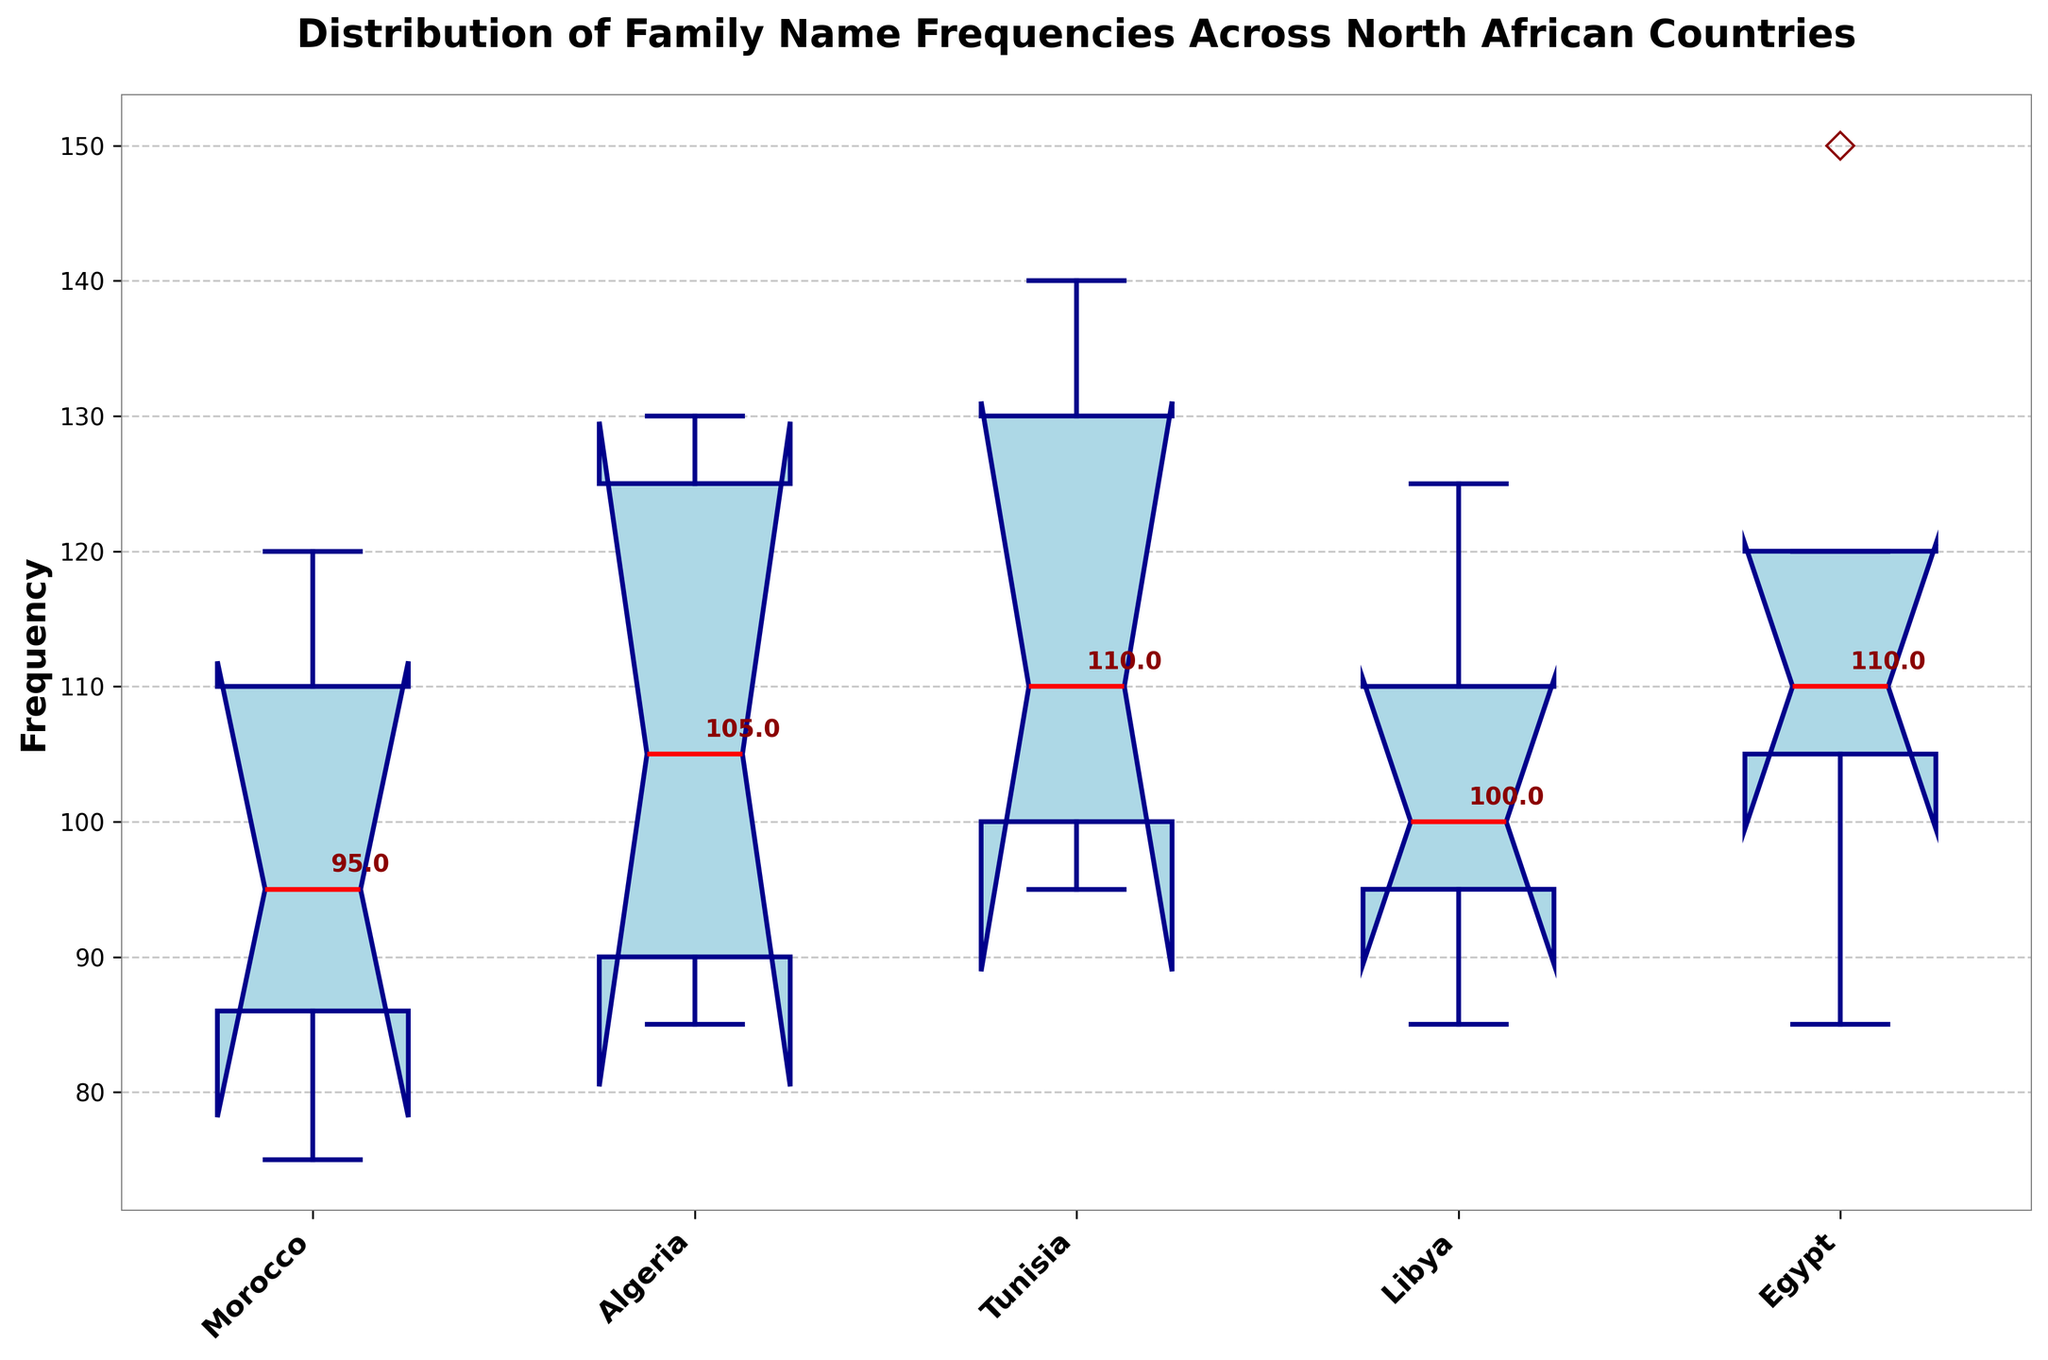What's the title of the figure? The title is usually located at the top of the plot. In this case, it reads "Distribution of Family Name Frequencies Across North African Countries".
Answer: Distribution of Family Name Frequencies Across North African Countries What information is displayed on the y-axis? The y-axis in this figure shows the frequency of family names. This can be identified by the label "Frequency" on the y-axis.
Answer: Frequency Which country has the highest median family name frequency? The median values are identified by the red lines within the boxes. We can look at each country and see which median line is at the highest y-value. In this case, Tunisia seems to have the highest median.
Answer: Tunisia What is the range of the family name frequencies for Morocco? The range consists of the difference between the maximum and minimum values within the whiskers for Morocco. The box plot for Morocco shows that the maximum is about 120 and the minimum is about 75. Therefore, the range is 120 - 75 = 45.
Answer: 45 Which country has the most outliers? Outliers are represented by points outside the whiskers of the box plot, generally marked with distinct symbols like a diamond. Observing the plot, Tunisia has the highest number of outliers.
Answer: Tunisia What do the notches in the box plots represent? Notches in a box plot represent a confidence interval around the median, usually a 95% confidence interval. This helps indicate if medians are significantly different; if the notches of two boxes do not overlap, it suggests a statistically significant difference in medians.
Answer: Confidence interval around the median Which country has the smallest interquartile range (IQR)? The IQR is the length of the box in each box plot. By visually inspecting the height of the boxes, Algeria appears to have the smallest IQR.
Answer: Algeria Compare the median frequency of family names between Egypt and Libya. Which one is higher? To compare the medians, look at the red lines within the boxes for Egypt and Libya. The median value for Egypt is higher than that for Libya.
Answer: Egypt What can be inferred if the notches of two box plots do not overlap? When the notches of two box plots do not overlap, it suggests there is a statistically significant difference between the medians of the two groups. This can be inferred based on the construction of notches representing confidence intervals.
Answer: Statistically significant difference between medians How can the presence of outliers affect the interpretation of the data for a specific country? The presence of outliers indicates that there are family names with frequencies significantly different from the rest of the data set. This can impact the analysis by indicating higher variability or suggesting the need to investigate those specific family names further.
Answer: Higher variability or need for further investigation 